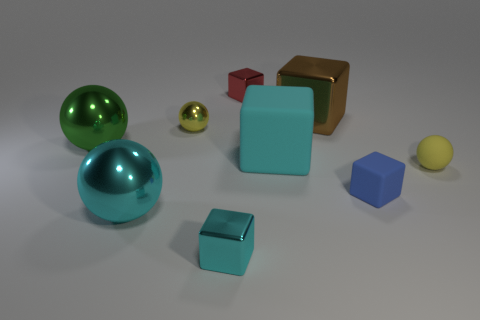Subtract 2 blocks. How many blocks are left? 3 Subtract all red cubes. How many cubes are left? 4 Subtract all tiny red blocks. How many blocks are left? 4 Add 1 small blue matte cubes. How many objects exist? 10 Subtract all green blocks. Subtract all purple balls. How many blocks are left? 5 Subtract all spheres. How many objects are left? 5 Add 6 big green things. How many big green things exist? 7 Subtract 0 cyan cylinders. How many objects are left? 9 Subtract all cyan blocks. Subtract all tiny red things. How many objects are left? 6 Add 4 cyan things. How many cyan things are left? 7 